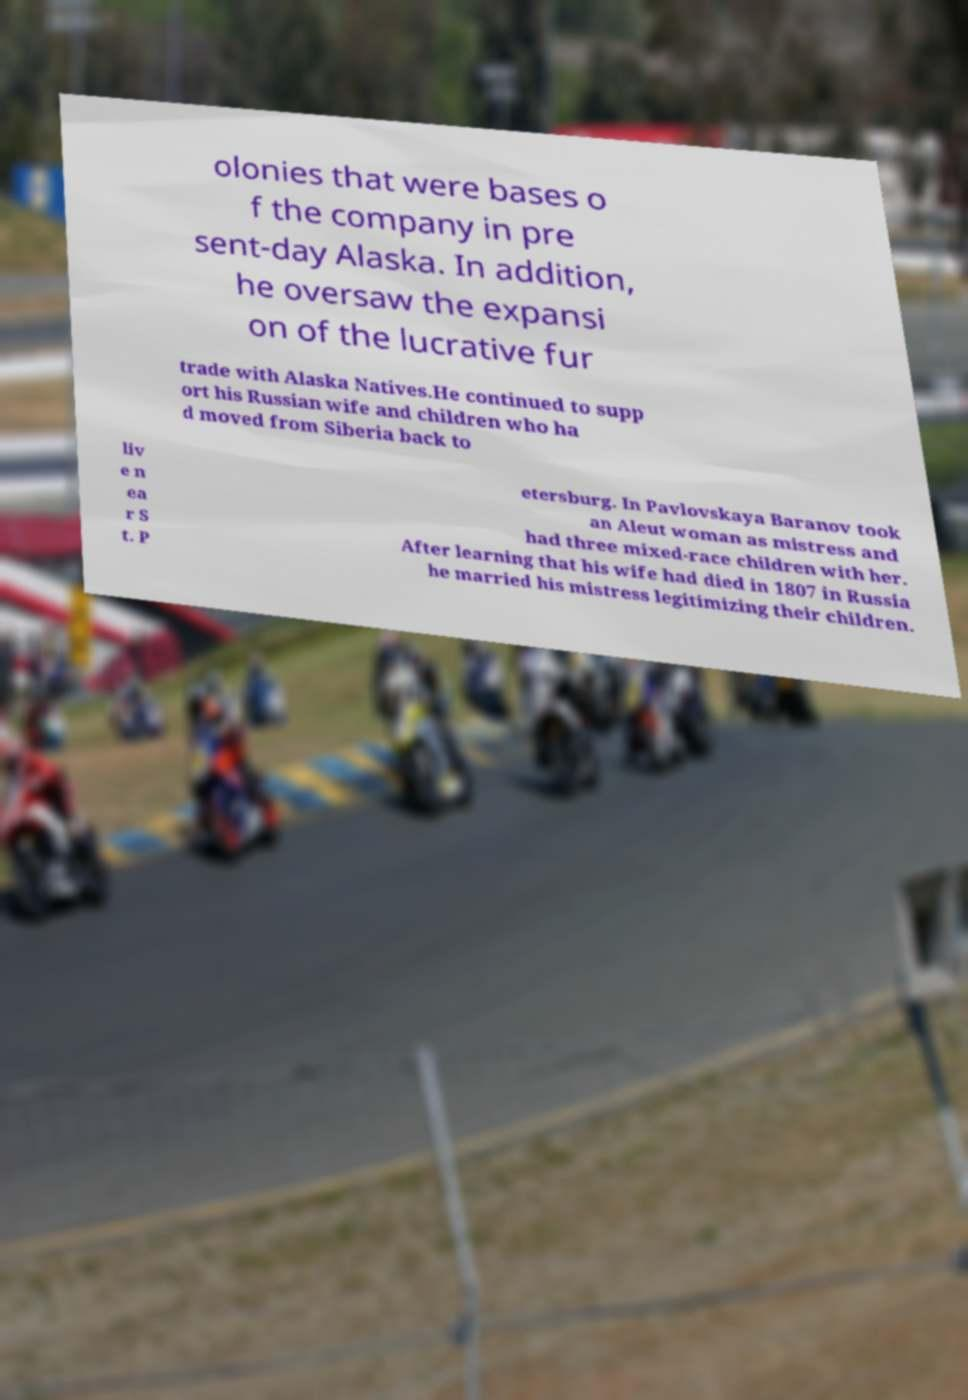Could you assist in decoding the text presented in this image and type it out clearly? olonies that were bases o f the company in pre sent-day Alaska. In addition, he oversaw the expansi on of the lucrative fur trade with Alaska Natives.He continued to supp ort his Russian wife and children who ha d moved from Siberia back to liv e n ea r S t. P etersburg. In Pavlovskaya Baranov took an Aleut woman as mistress and had three mixed-race children with her. After learning that his wife had died in 1807 in Russia he married his mistress legitimizing their children. 